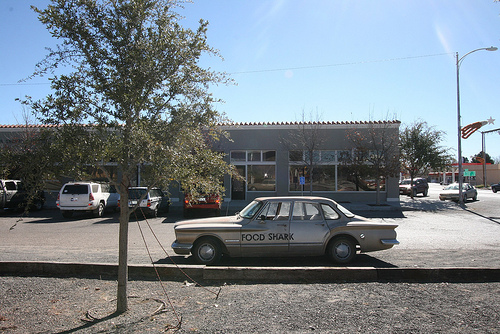<image>
Is the tree behind the car? No. The tree is not behind the car. From this viewpoint, the tree appears to be positioned elsewhere in the scene. Is the tree next to the car? Yes. The tree is positioned adjacent to the car, located nearby in the same general area. 